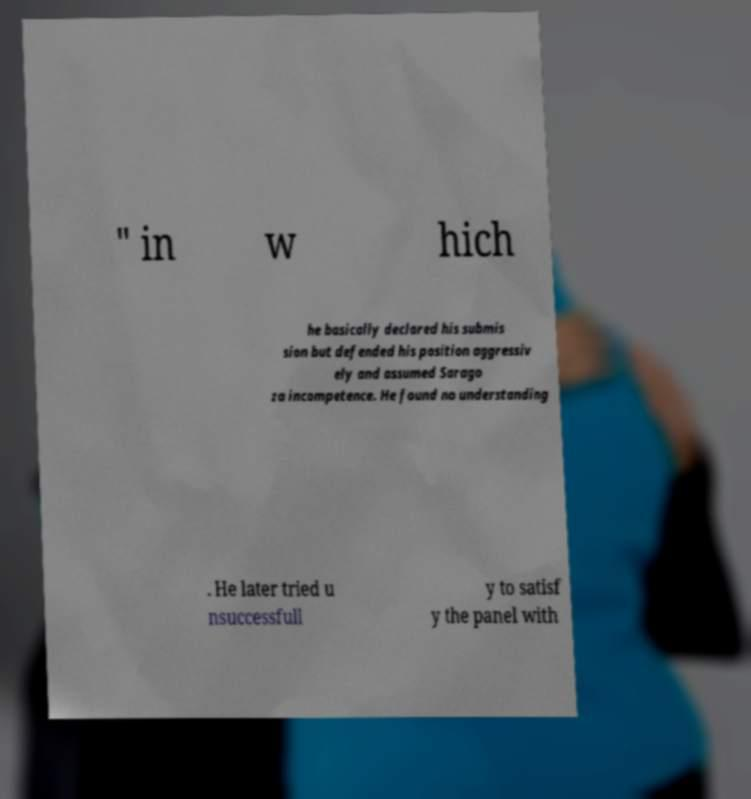For documentation purposes, I need the text within this image transcribed. Could you provide that? " in w hich he basically declared his submis sion but defended his position aggressiv ely and assumed Sarago za incompetence. He found no understanding . He later tried u nsuccessfull y to satisf y the panel with 